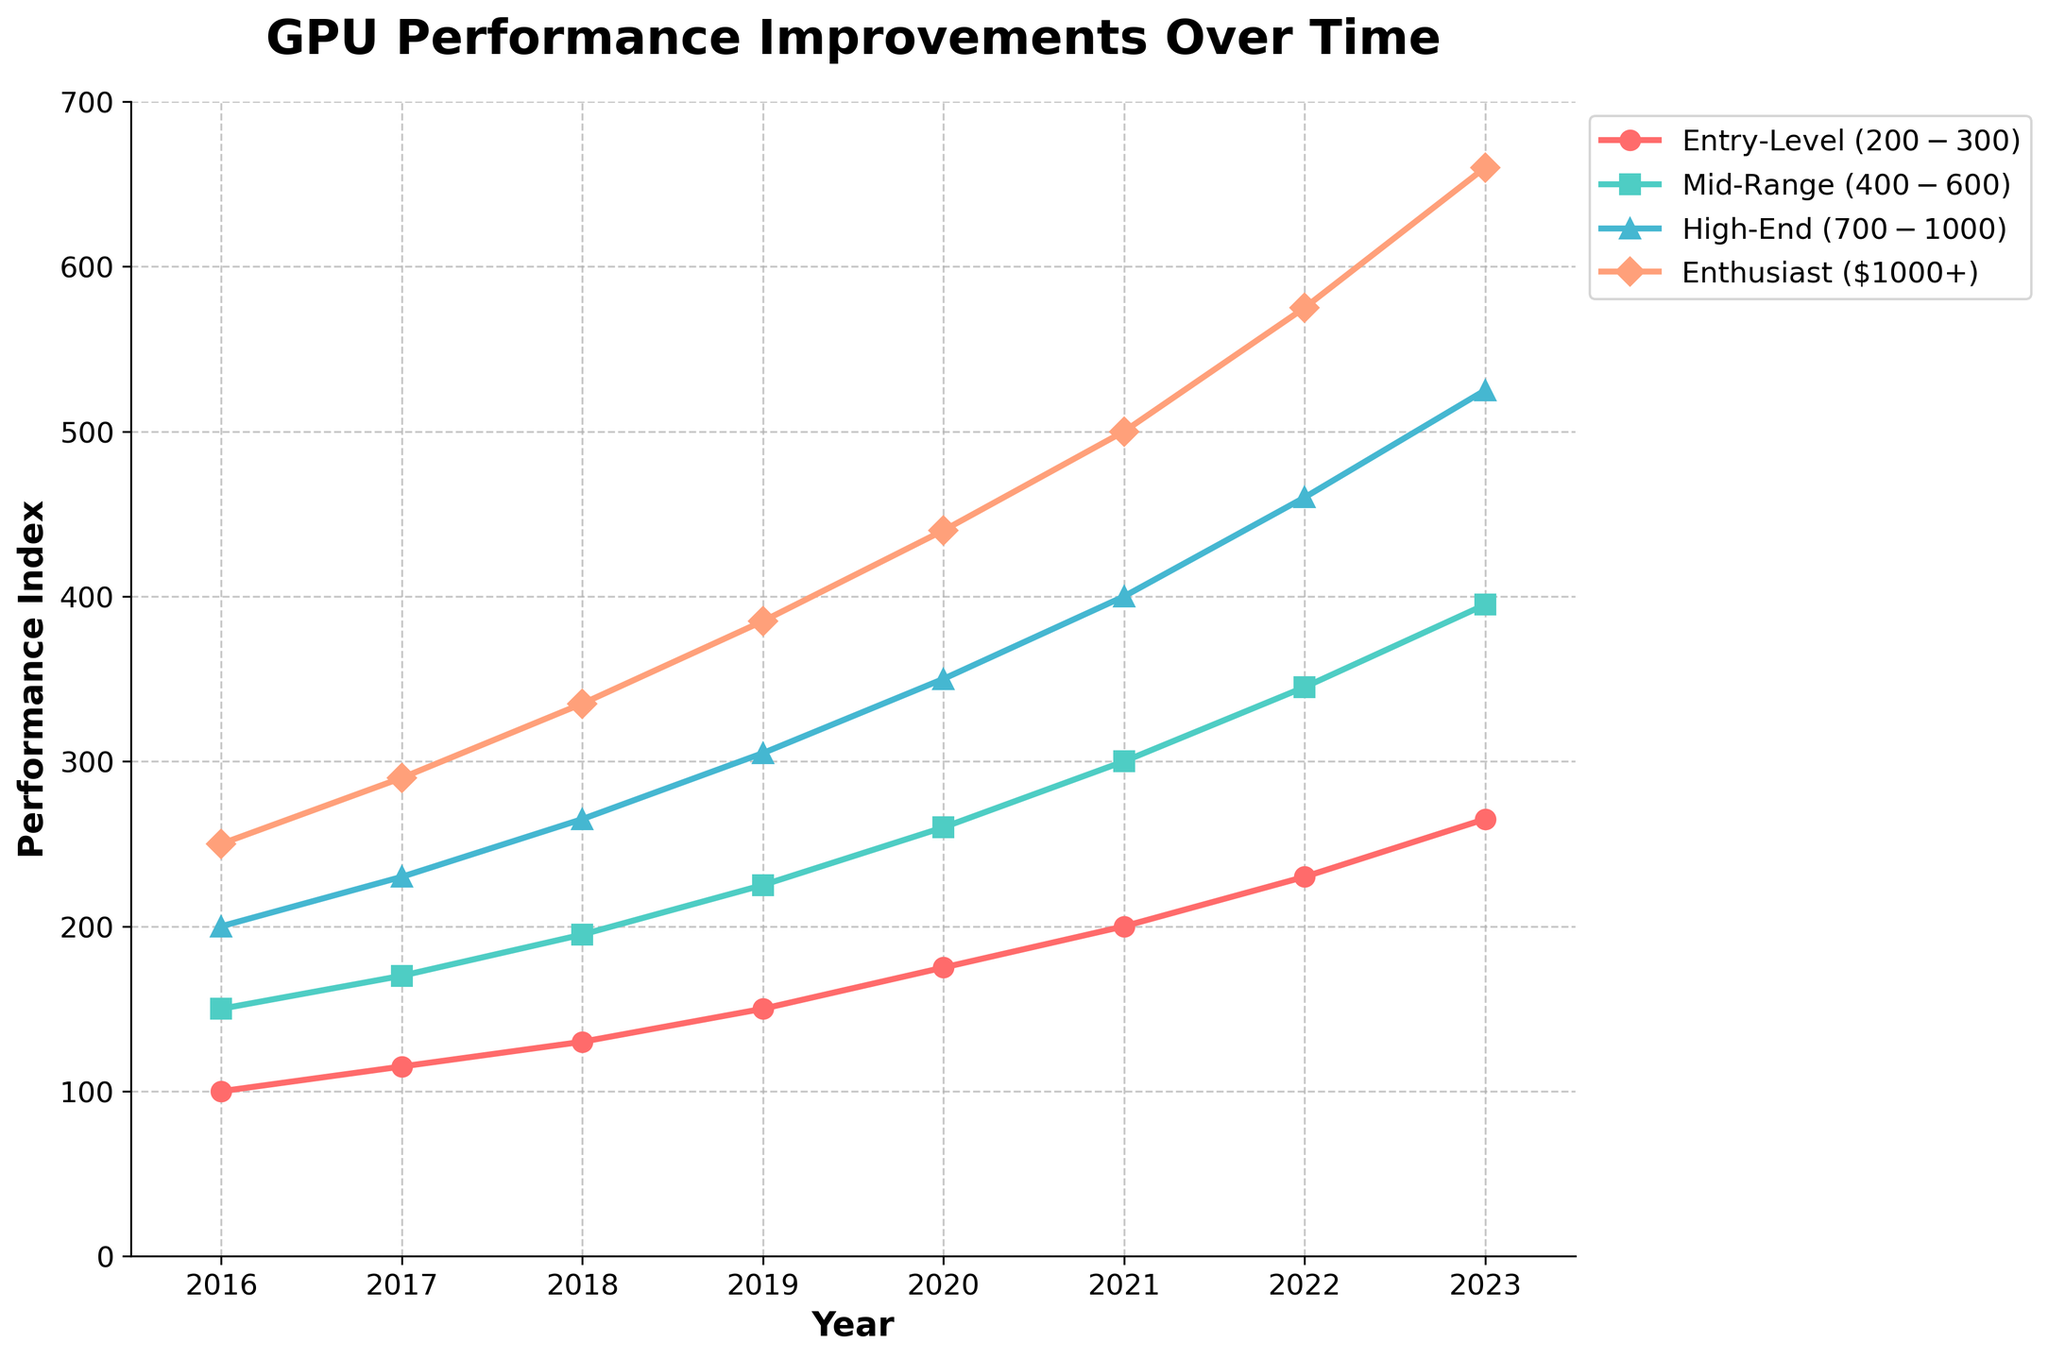What year did the Mid-Range tier start to surpass 200 in performance? To determine this, locate the Mid-Range line and identify the year when it first crosses the performance value of 200.
Answer: 2019 From 2016 to 2023, what is the performance increase for the Entry-Level tier? Find the difference between the performance value in 2023 and the performance value in 2016 for the Entry-Level tier. The values are 265 in 2023 and 100 in 2016. Subtract 100 from 265.
Answer: 165 Which tier shows the most significant increase in performance from 2017 to 2023? Calculate the performance increase for each tier by subtracting the 2017 value from the 2023 value and compare them. Entry-Level: 265-115 = 150, Mid-Range: 395-170 = 225, High-End: 525-230 = 295, Enthusiast: 660-290 = 370. The highest increase is for the Enthusiast tier.
Answer: Enthusiast What is the average performance value of the High-End tier across all years? Sum all the performance values for the High-End tier and divide by the number of years. The values are 200, 230, 265, 305, 350, 400, 460, 525. Sum is 2735 and there are 8 years. Calculate 2735/8.
Answer: 341.875 Visually, which tier has the steepest incline over all the years? To determine the steepest incline, observe the slope of each line. The line with the steepest incline will appear most vertical.
Answer: Enthusiast By how much does the performance of the Mid-Range tier in 2023 exceed the Entry-Level tier in the same year? Subtract the 2023 performance value of the Entry-Level tier from the Mid-Range tier's value. The values are 395 for Mid-Range and 265 for Entry-Level, so 395-265.
Answer: 130 In what year did the High-End tier cross the 300 performance mark? Locate the year when the High-End tier's performance value exceeds 300.
Answer: 2019 What is the difference in performance value between 2020 and 2023 for the Entry-Level tier? Subtract the value in 2020 from the value in 2023 for the Entry-Level tier. The values are 265 in 2023 and 175 in 2020, so 265-175.
Answer: 90 Comparing all tiers in the year 2021, which tier has the lowest performance, and what is its value? Look at the performance values for all tiers in 2021 and identify the smallest one. The values are Entry-Level: 200, Mid-Range: 300, High-End: 400, Enthusiast: 500. The lowest is for the Entry-Level.
Answer: Entry-Level, 200 